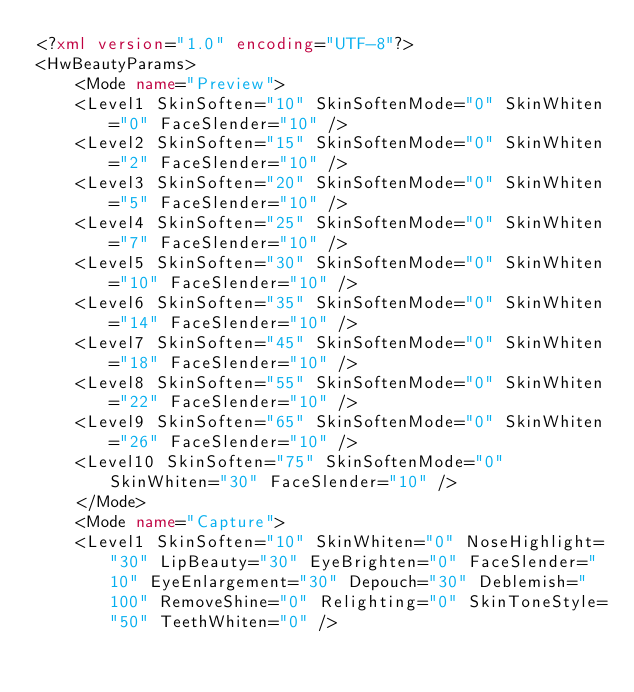<code> <loc_0><loc_0><loc_500><loc_500><_XML_><?xml version="1.0" encoding="UTF-8"?>
<HwBeautyParams>
	<Mode name="Preview">
	<Level1 SkinSoften="10" SkinSoftenMode="0" SkinWhiten="0" FaceSlender="10" />
	<Level2 SkinSoften="15" SkinSoftenMode="0" SkinWhiten="2" FaceSlender="10" />
	<Level3 SkinSoften="20" SkinSoftenMode="0" SkinWhiten="5" FaceSlender="10" />
	<Level4 SkinSoften="25" SkinSoftenMode="0" SkinWhiten="7" FaceSlender="10" />
	<Level5 SkinSoften="30" SkinSoftenMode="0" SkinWhiten="10" FaceSlender="10" />
	<Level6 SkinSoften="35" SkinSoftenMode="0" SkinWhiten="14" FaceSlender="10" />
	<Level7 SkinSoften="45" SkinSoftenMode="0" SkinWhiten="18" FaceSlender="10" />
	<Level8 SkinSoften="55" SkinSoftenMode="0" SkinWhiten="22" FaceSlender="10" />
	<Level9 SkinSoften="65" SkinSoftenMode="0" SkinWhiten="26" FaceSlender="10" />
	<Level10 SkinSoften="75" SkinSoftenMode="0" SkinWhiten="30" FaceSlender="10" />
	</Mode>
	<Mode name="Capture">
	<Level1 SkinSoften="10" SkinWhiten="0" NoseHighlight="30" LipBeauty="30" EyeBrighten="0" FaceSlender="10" EyeEnlargement="30" Depouch="30" Deblemish="100" RemoveShine="0" Relighting="0" SkinToneStyle="50" TeethWhiten="0" /></code> 